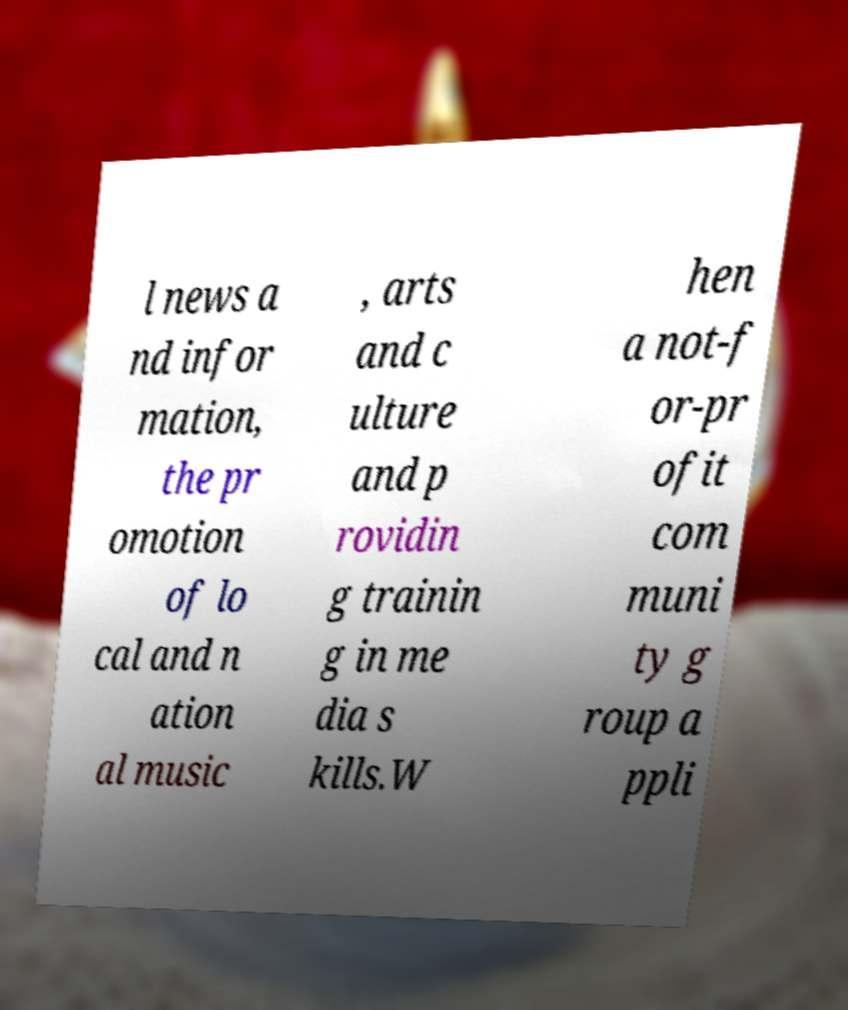Could you assist in decoding the text presented in this image and type it out clearly? l news a nd infor mation, the pr omotion of lo cal and n ation al music , arts and c ulture and p rovidin g trainin g in me dia s kills.W hen a not-f or-pr ofit com muni ty g roup a ppli 